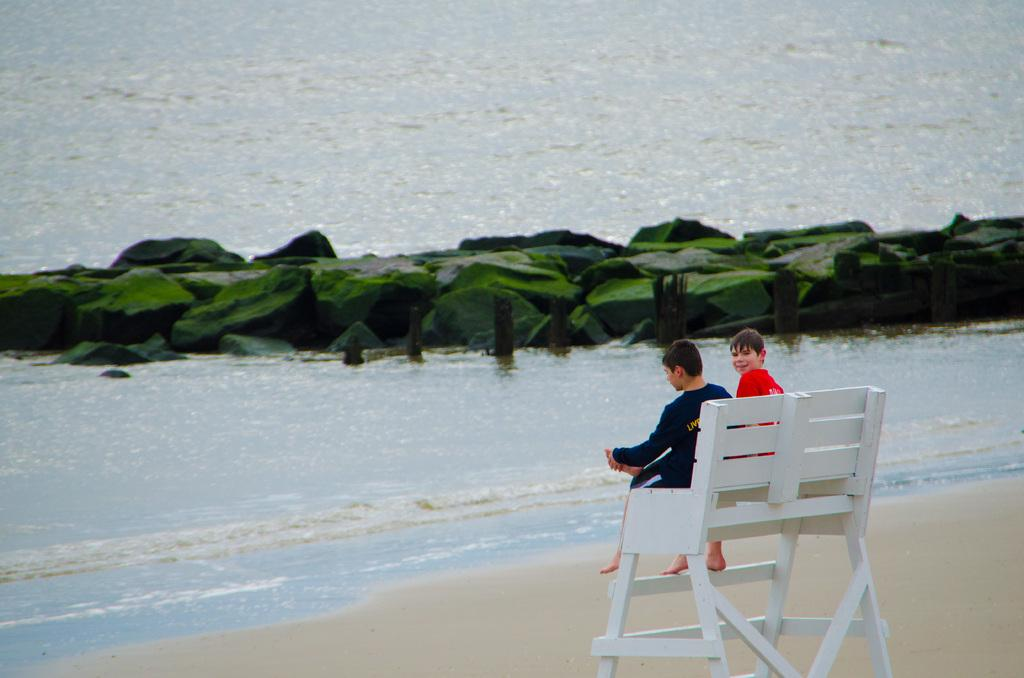What can be seen on the right side of the image? There are kids sitting on a bench chair on the right side of the image. What is located in the middle of the image? There is water in the middle of the image. What is present in the water? There are stones in the water. What is the income of the actor sitting on the bench chair in the image? There is no actor present in the image, and therefore no income can be determined. What type of corn can be seen growing in the water? There is no corn present in the image; it features kids sitting on a bench chair and water with stones. 